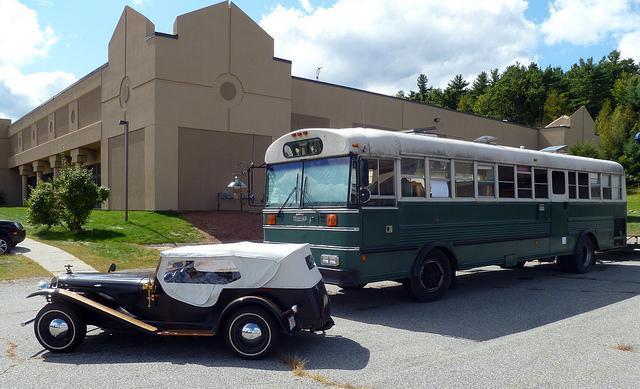How many blue barrels are there?
Give a very brief answer. 0. 